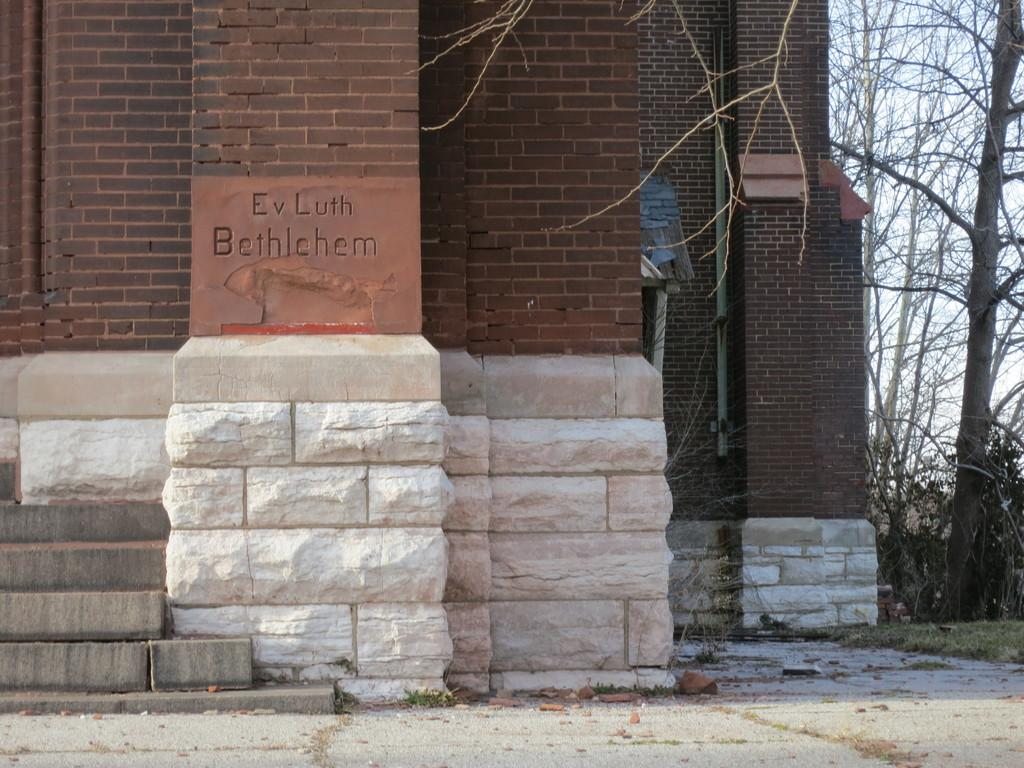What can be seen in the background of the image? There is a wall in the background of the image. What is written on the wall? There is text written on the wall. What type of vegetation is on the right side of the image? There are trees on the right side of the image. What is the ground covered with in the image? There is grass on the ground. Can you tell me how many zebras are grazing in the yard in the image? There are no zebras present in the image, and the term "yard" is not mentioned in the provided facts. 